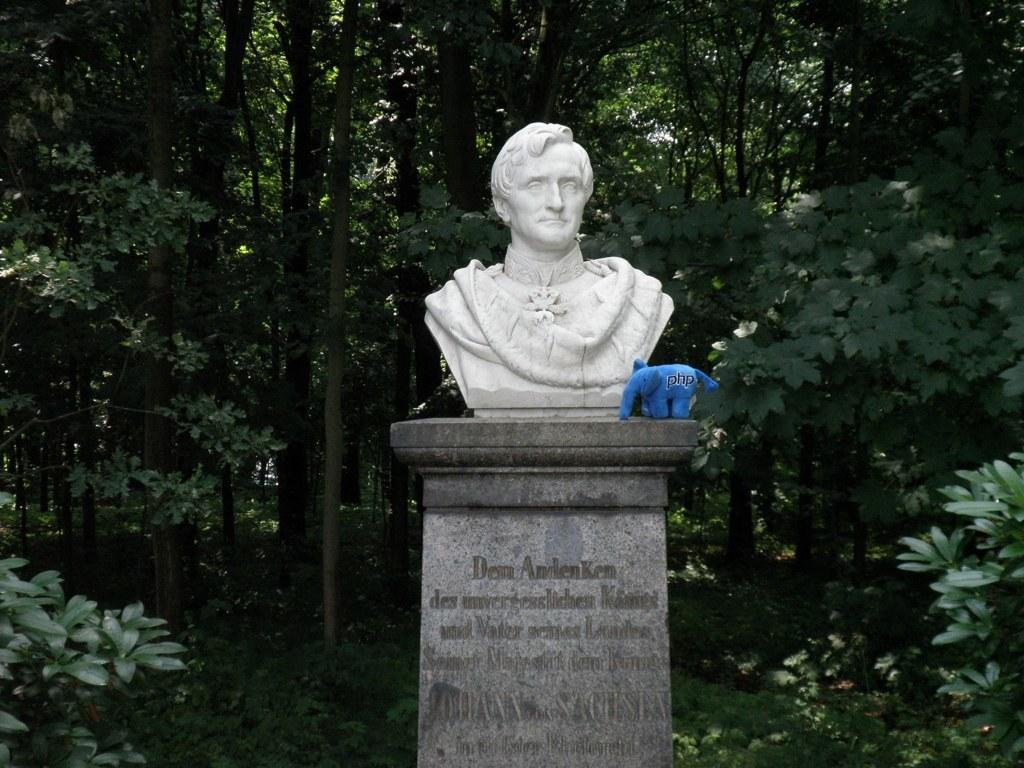What is the main subject in the image? There is a sculpture in the image. What other object can be seen in the image? There is a toy elephant placed on a stand in the image. Are there any words or text on the sculpture or toy elephant? Yes, the sculpture and toy elephant have some text on them. What type of natural elements are present in the image? There is a group of trees and plants in the image. How many cats are sitting on the sculpture in the image? There are no cats present in the image; it features a sculpture and a toy elephant with text on them, along with a group of trees and plants. 